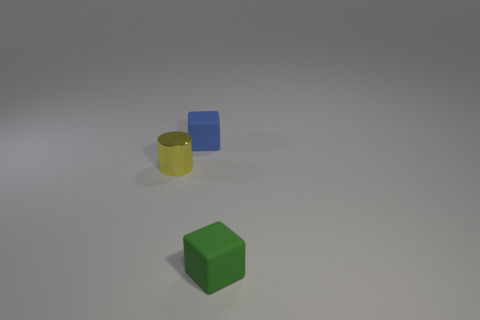Are there any shadows cast by the objects, and what can you infer from them? Yes, there are shadows cast by each object, stretching toward the right of the image, suggesting a light source is coming from the left. The softness and angle of the shadows may indicate the light's distance and strength, contributing to the sense of depth in the image. 